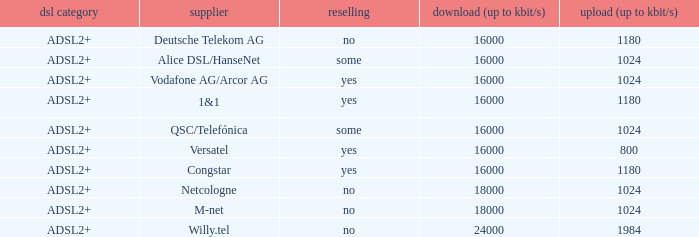What is the resale category for the provider NetCologne? No. 